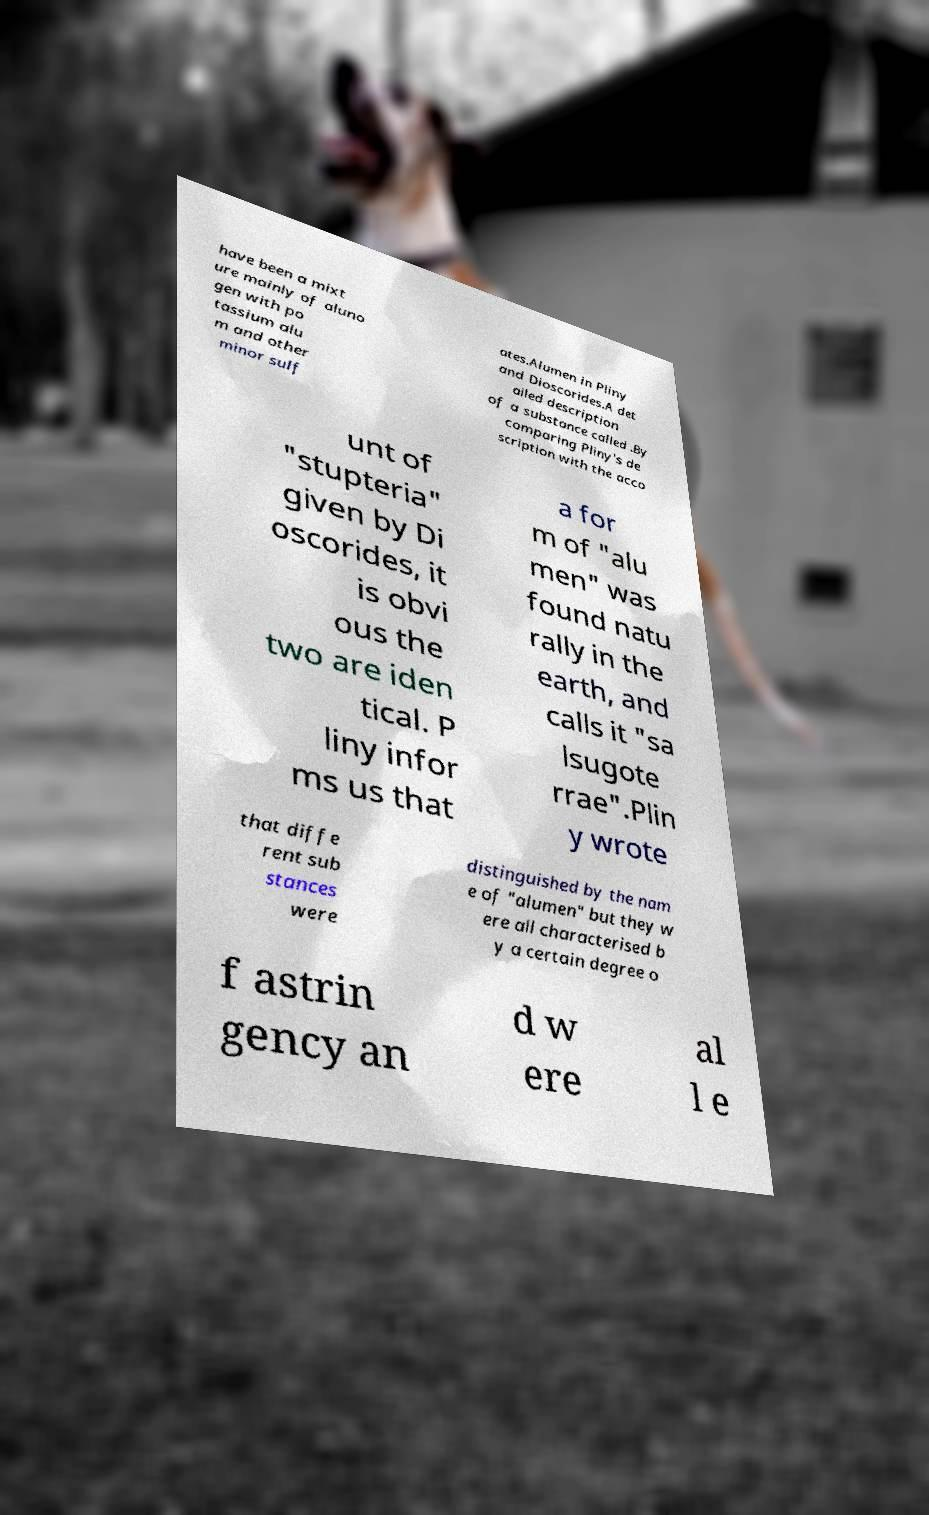Please identify and transcribe the text found in this image. have been a mixt ure mainly of aluno gen with po tassium alu m and other minor sulf ates.Alumen in Pliny and Dioscorides.A det ailed description of a substance called .By comparing Pliny's de scription with the acco unt of "stupteria" given by Di oscorides, it is obvi ous the two are iden tical. P liny infor ms us that a for m of "alu men" was found natu rally in the earth, and calls it "sa lsugote rrae".Plin y wrote that diffe rent sub stances were distinguished by the nam e of "alumen" but they w ere all characterised b y a certain degree o f astrin gency an d w ere al l e 